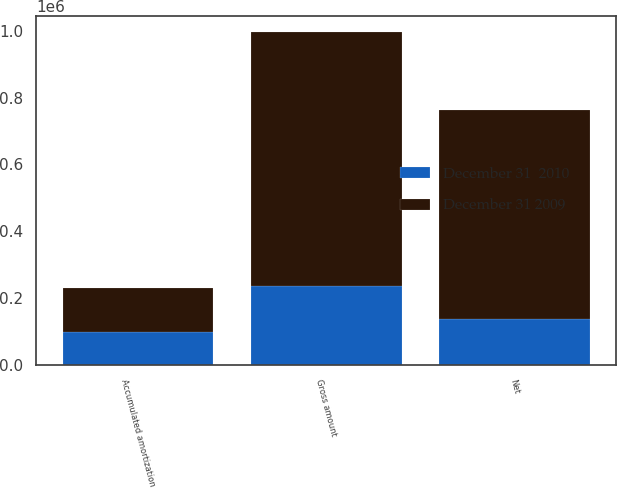Convert chart. <chart><loc_0><loc_0><loc_500><loc_500><stacked_bar_chart><ecel><fcel>Gross amount<fcel>Accumulated amortization<fcel>Net<nl><fcel>December 31 2009<fcel>758300<fcel>133737<fcel>624563<nl><fcel>December 31  2010<fcel>236594<fcel>98090<fcel>138504<nl></chart> 